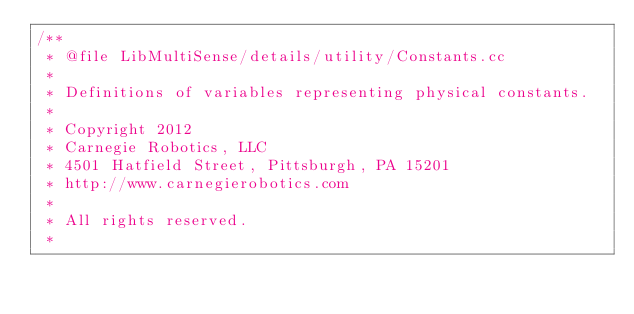Convert code to text. <code><loc_0><loc_0><loc_500><loc_500><_C++_>/**
 * @file LibMultiSense/details/utility/Constants.cc
 *
 * Definitions of variables representing physical constants.
 *
 * Copyright 2012
 * Carnegie Robotics, LLC
 * 4501 Hatfield Street, Pittsburgh, PA 15201
 * http://www.carnegierobotics.com
 *
 * All rights reserved.
 *</code> 